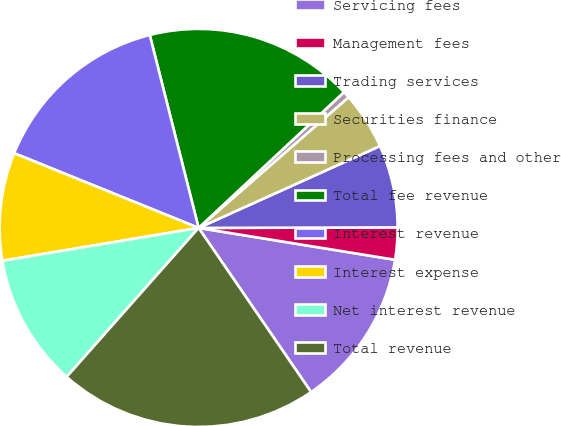Convert chart. <chart><loc_0><loc_0><loc_500><loc_500><pie_chart><fcel>Servicing fees<fcel>Management fees<fcel>Trading services<fcel>Securities finance<fcel>Processing fees and other<fcel>Total fee revenue<fcel>Interest revenue<fcel>Interest expense<fcel>Net interest revenue<fcel>Total revenue<nl><fcel>12.88%<fcel>2.6%<fcel>6.71%<fcel>4.66%<fcel>0.55%<fcel>16.99%<fcel>14.93%<fcel>8.77%<fcel>10.82%<fcel>21.1%<nl></chart> 